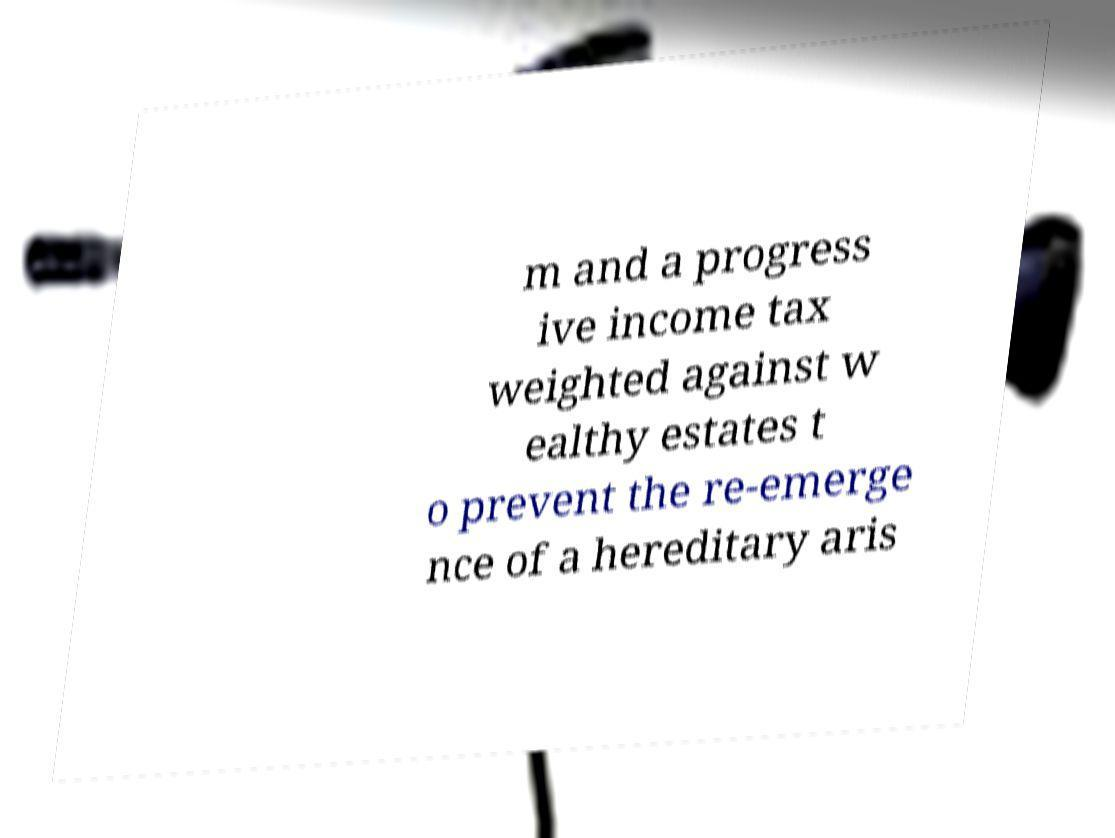There's text embedded in this image that I need extracted. Can you transcribe it verbatim? m and a progress ive income tax weighted against w ealthy estates t o prevent the re-emerge nce of a hereditary aris 